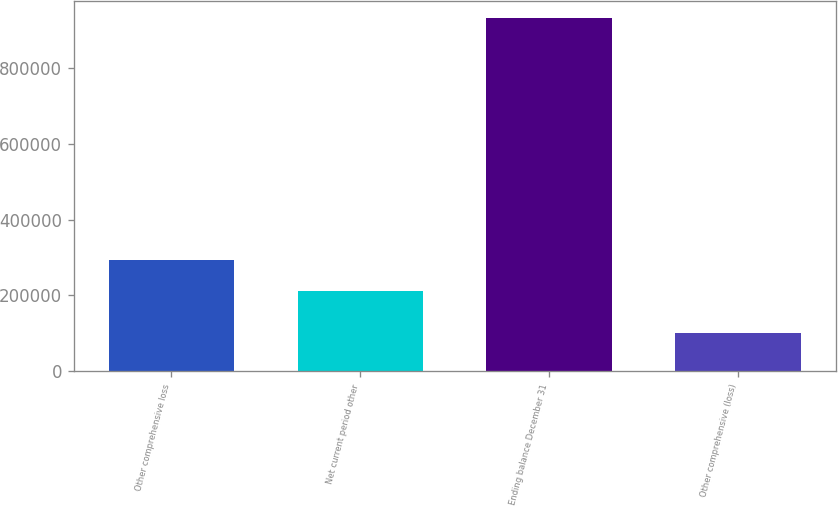<chart> <loc_0><loc_0><loc_500><loc_500><bar_chart><fcel>Other comprehensive loss<fcel>Net current period other<fcel>Ending balance December 31<fcel>Other comprehensive (loss)<nl><fcel>293299<fcel>210407<fcel>930618<fcel>101700<nl></chart> 